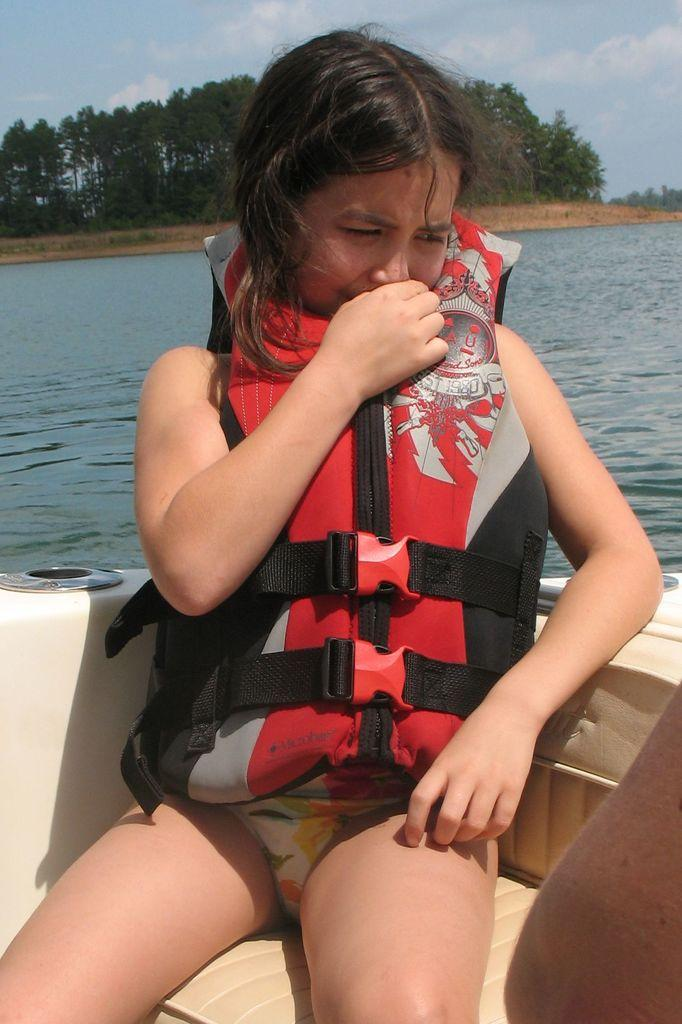What is the girl doing in the image? The girl is sitting on a boat in the image. What is the girl's expression in the image? The girl is smiling in the image. What can be seen in the background of the image? There is water, trees, and a cloudy sky visible in the background of the image. Who is the creator of the receipt in the image? There is no receipt present in the image. 